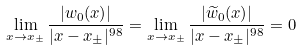Convert formula to latex. <formula><loc_0><loc_0><loc_500><loc_500>\lim _ { x \rightarrow x _ { \pm } } \frac { | w _ { 0 } ( x ) | } { | x - x _ { \pm } | ^ { 9 8 } } = \lim _ { x \rightarrow x _ { \pm } } \frac { | \widetilde { w } _ { 0 } ( x ) | } { | x - x _ { \pm } | ^ { 9 8 } } = 0</formula> 